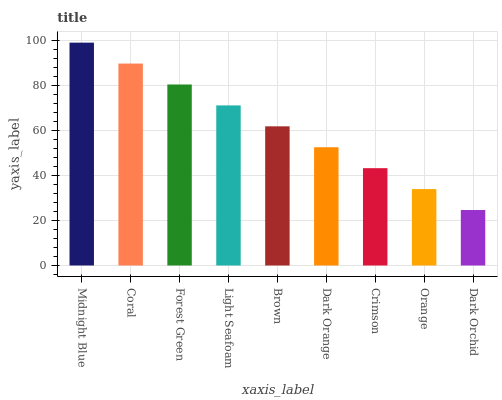Is Dark Orchid the minimum?
Answer yes or no. Yes. Is Midnight Blue the maximum?
Answer yes or no. Yes. Is Coral the minimum?
Answer yes or no. No. Is Coral the maximum?
Answer yes or no. No. Is Midnight Blue greater than Coral?
Answer yes or no. Yes. Is Coral less than Midnight Blue?
Answer yes or no. Yes. Is Coral greater than Midnight Blue?
Answer yes or no. No. Is Midnight Blue less than Coral?
Answer yes or no. No. Is Brown the high median?
Answer yes or no. Yes. Is Brown the low median?
Answer yes or no. Yes. Is Dark Orchid the high median?
Answer yes or no. No. Is Light Seafoam the low median?
Answer yes or no. No. 